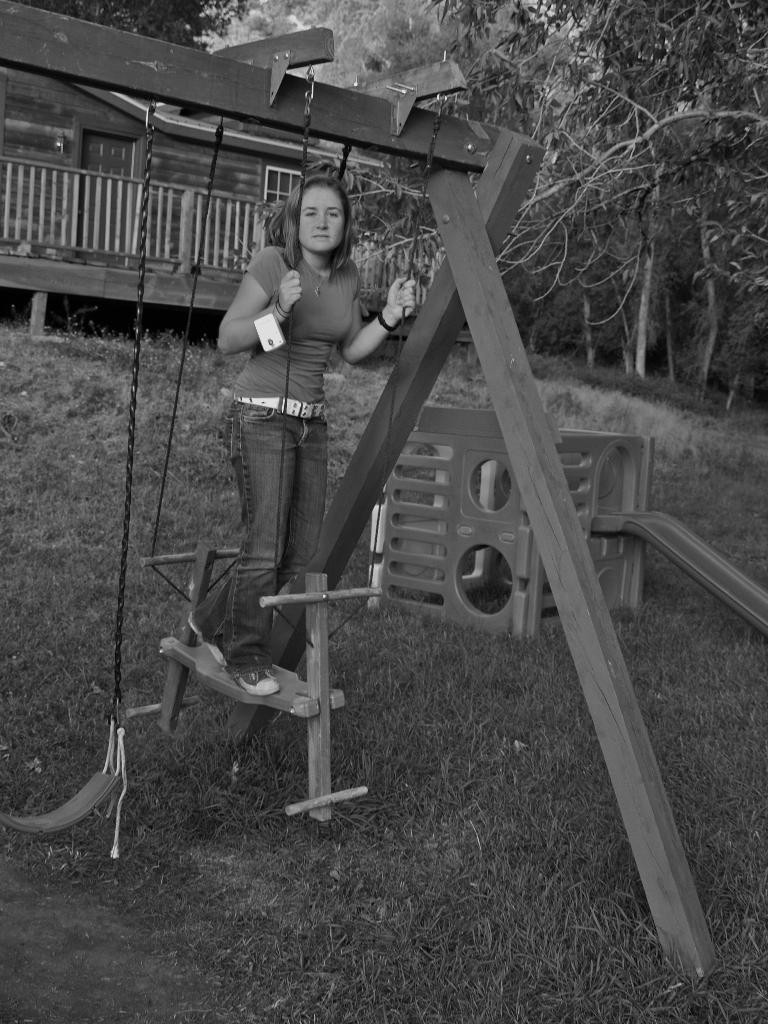Who is present in the image? There is a lady in the image. What is the lady sitting on? The lady is on a wooden object. What type of playground equipment can be seen in the image? There is a swing in the image. What type of building is visible in the image? There is a house in the image. What type of natural vegetation is present in the image? There are trees in the image. What type of wood is the sugar made from in the image? There is no sugar or reference to wood in the image; it features a lady on a wooden object and a swing. 